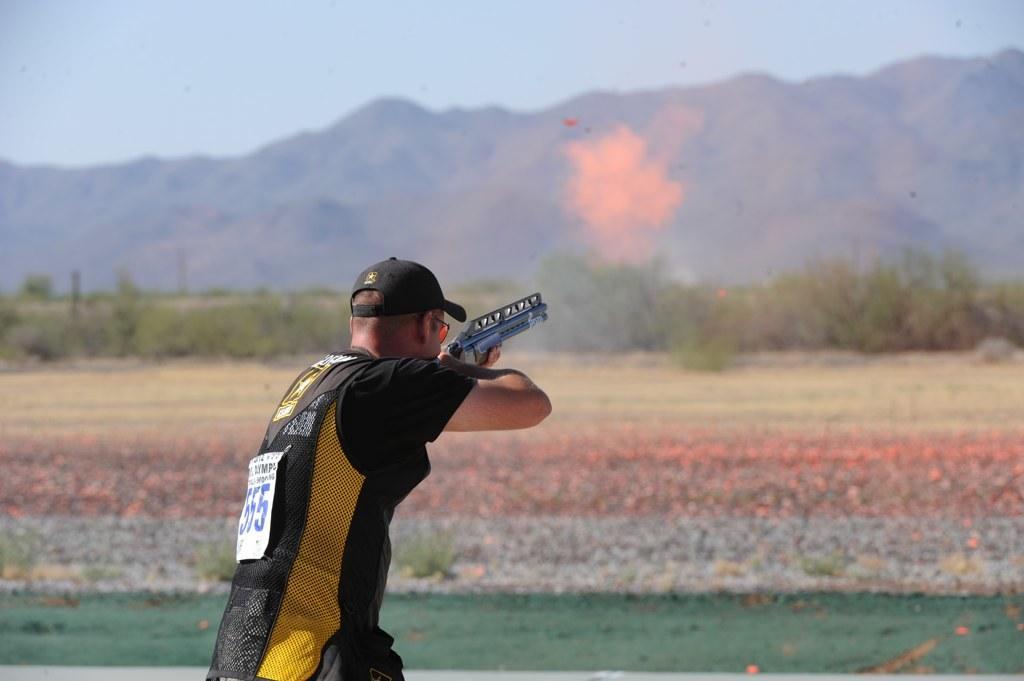In one or two sentences, can you explain what this image depicts? In this picture we can see a person holding a gun and in the background we can see trees, mountains and sky. 